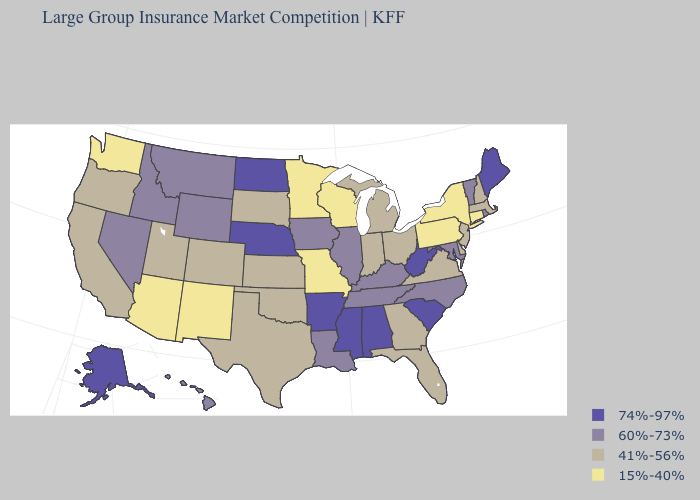Name the states that have a value in the range 15%-40%?
Be succinct. Arizona, Connecticut, Minnesota, Missouri, New Mexico, New York, Pennsylvania, Washington, Wisconsin. What is the lowest value in the West?
Short answer required. 15%-40%. What is the value of New Mexico?
Quick response, please. 15%-40%. What is the lowest value in states that border Arkansas?
Quick response, please. 15%-40%. Does the first symbol in the legend represent the smallest category?
Short answer required. No. What is the lowest value in the MidWest?
Quick response, please. 15%-40%. What is the value of Washington?
Write a very short answer. 15%-40%. Name the states that have a value in the range 60%-73%?
Quick response, please. Hawaii, Idaho, Illinois, Iowa, Kentucky, Louisiana, Maryland, Montana, Nevada, North Carolina, Rhode Island, Tennessee, Vermont, Wyoming. Which states hav the highest value in the South?
Give a very brief answer. Alabama, Arkansas, Mississippi, South Carolina, West Virginia. Name the states that have a value in the range 15%-40%?
Answer briefly. Arizona, Connecticut, Minnesota, Missouri, New Mexico, New York, Pennsylvania, Washington, Wisconsin. Among the states that border Delaware , does Pennsylvania have the lowest value?
Give a very brief answer. Yes. Does the map have missing data?
Concise answer only. No. What is the value of Oregon?
Be succinct. 41%-56%. What is the value of Pennsylvania?
Short answer required. 15%-40%. 